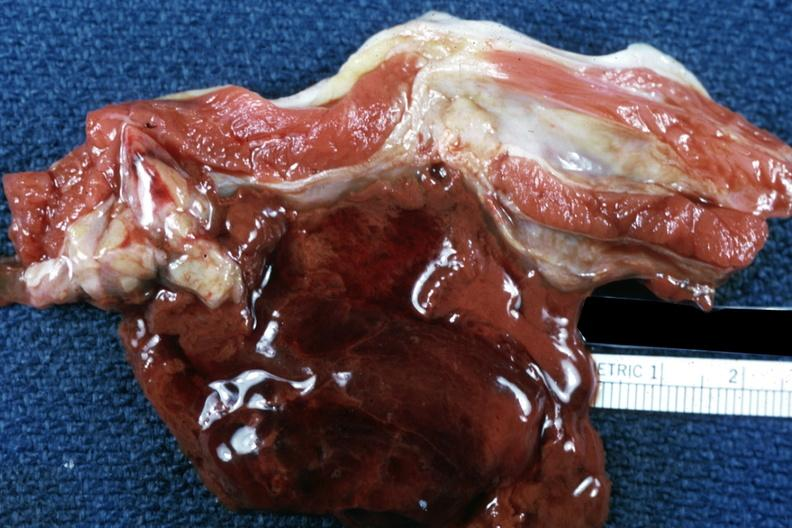what is present?
Answer the question using a single word or phrase. Soft tissue 